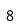Convert formula to latex. <formula><loc_0><loc_0><loc_500><loc_500>8</formula> 